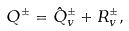<formula> <loc_0><loc_0><loc_500><loc_500>Q ^ { \pm } = \hat { Q } ^ { \pm } _ { v } + R ^ { \pm } _ { v } ,</formula> 